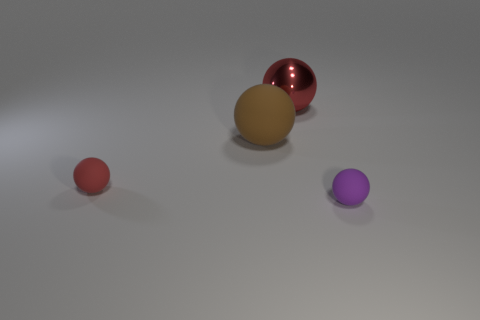What shape is the thing that is both left of the big shiny object and on the right side of the red matte object?
Make the answer very short. Sphere. There is a red rubber object that is to the left of the tiny rubber object right of the metallic sphere; how big is it?
Ensure brevity in your answer.  Small. What number of other small objects have the same shape as the metallic object?
Offer a terse response. 2. Do the big rubber sphere and the shiny sphere have the same color?
Keep it short and to the point. No. Is there anything else that is the same shape as the brown thing?
Keep it short and to the point. Yes. Are there any small things that have the same color as the large matte thing?
Keep it short and to the point. No. Is the material of the big sphere that is right of the large brown thing the same as the small ball on the right side of the metal thing?
Your response must be concise. No. What is the color of the big rubber object?
Provide a short and direct response. Brown. What is the size of the matte object behind the red rubber sphere on the left side of the small object that is on the right side of the brown rubber thing?
Make the answer very short. Large. How many other things are there of the same size as the brown object?
Your response must be concise. 1. 